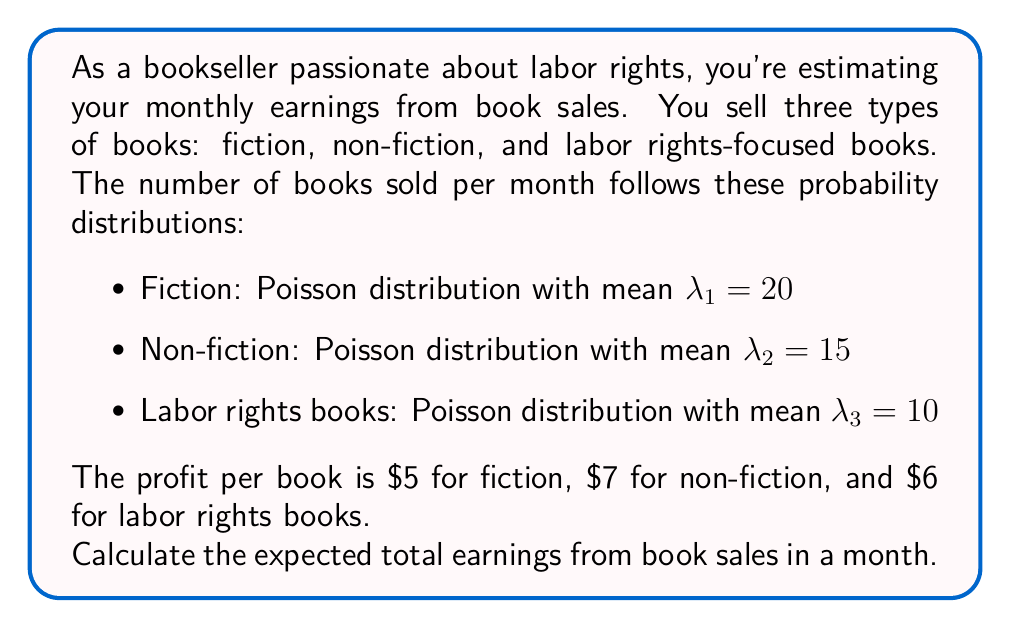Could you help me with this problem? To solve this problem, we'll follow these steps:

1) First, recall that for a Poisson distribution with mean $\lambda$, the expected value is equal to $\lambda$.

2) For each book type, we need to calculate the expected earnings:

   a) Fiction:
      Expected number of books sold = $\lambda_1 = 20$
      Profit per book = $5
      Expected earnings = $20 \times $5 = $100

   b) Non-fiction:
      Expected number of books sold = $\lambda_2 = 15$
      Profit per book = $7
      Expected earnings = $15 \times $7 = $105

   c) Labor rights books:
      Expected number of books sold = $\lambda_3 = 10$
      Profit per book = $6
      Expected earnings = $10 \times $6 = $60

3) The total expected earnings is the sum of the expected earnings from each book type:

   Total expected earnings = $100 + $105 + $60 = $265

Therefore, the expected total earnings from book sales in a month is $265.
Answer: $265 